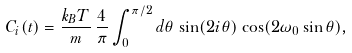Convert formula to latex. <formula><loc_0><loc_0><loc_500><loc_500>C _ { i } ( t ) = \frac { k _ { B } T } { m } \, \frac { 4 } { \pi } \int _ { 0 } ^ { \pi / 2 } d \theta \, \sin ( 2 i \theta ) \, \cos ( 2 \omega _ { 0 } \sin \theta ) ,</formula> 